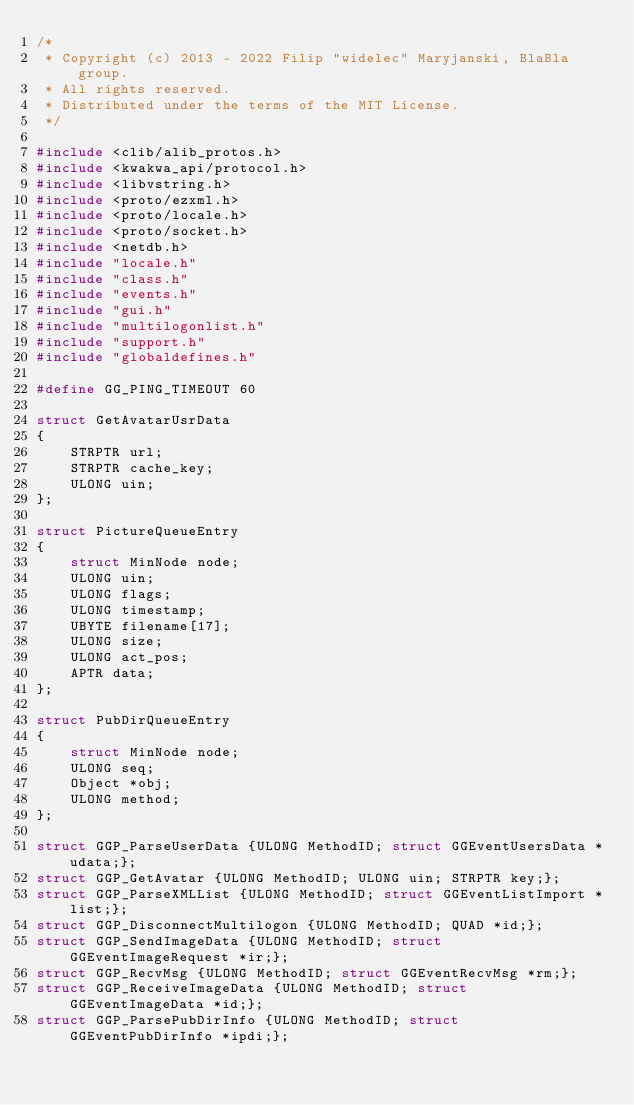<code> <loc_0><loc_0><loc_500><loc_500><_C_>/*
 * Copyright (c) 2013 - 2022 Filip "widelec" Maryjanski, BlaBla group.
 * All rights reserved.
 * Distributed under the terms of the MIT License.
 */

#include <clib/alib_protos.h>
#include <kwakwa_api/protocol.h>
#include <libvstring.h>
#include <proto/ezxml.h>
#include <proto/locale.h>
#include <proto/socket.h>
#include <netdb.h>
#include "locale.h"
#include "class.h"
#include "events.h"
#include "gui.h"
#include "multilogonlist.h"
#include "support.h"
#include "globaldefines.h"

#define GG_PING_TIMEOUT 60

struct GetAvatarUsrData
{
	STRPTR url;
	STRPTR cache_key;
	ULONG uin;
};

struct PictureQueueEntry
{
	struct MinNode node;
	ULONG uin;
	ULONG flags;
	ULONG timestamp;
	UBYTE filename[17];
	ULONG size;
	ULONG act_pos;
	APTR data;
};

struct PubDirQueueEntry
{
	struct MinNode node;
	ULONG seq;
	Object *obj;
	ULONG method;
};

struct GGP_ParseUserData {ULONG MethodID; struct GGEventUsersData *udata;};
struct GGP_GetAvatar {ULONG MethodID; ULONG uin; STRPTR key;};
struct GGP_ParseXMLList {ULONG MethodID; struct GGEventListImport *list;};
struct GGP_DisconnectMultilogon {ULONG MethodID; QUAD *id;};
struct GGP_SendImageData {ULONG MethodID; struct GGEventImageRequest *ir;};
struct GGP_RecvMsg {ULONG MethodID; struct GGEventRecvMsg *rm;};
struct GGP_ReceiveImageData {ULONG MethodID; struct GGEventImageData *id;};
struct GGP_ParsePubDirInfo {ULONG MethodID; struct GGEventPubDirInfo *ipdi;};
</code> 